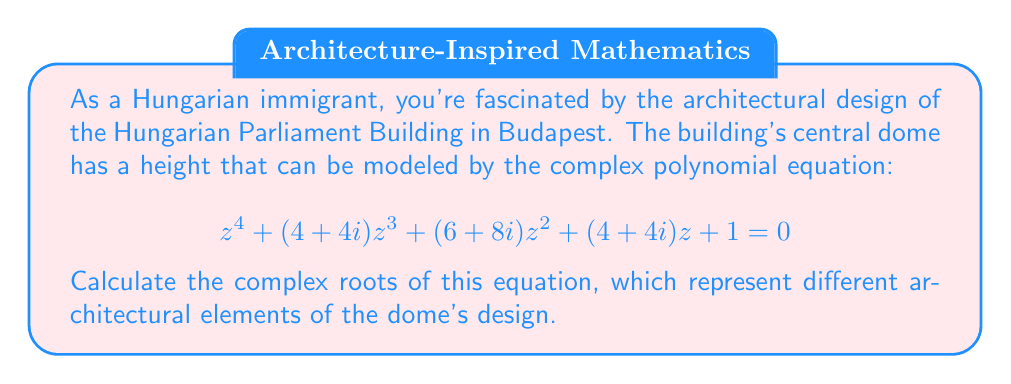Give your solution to this math problem. To solve this complex polynomial equation, we can use the following steps:

1) First, we recognize that this is a reciprocal polynomial, where the coefficients are symmetric. This means that if $z$ is a root, then $\frac{1}{z}$ is also a root.

2) We can factor the polynomial as:

   $$ (z^2 + az + 1)(z^2 + bz + 1) = 0 $$

   where $a$ and $b$ are complex numbers to be determined.

3) Expanding this factored form and equating coefficients with the original equation:

   $$ z^4 + (a+b)z^3 + (ab+2)z^2 + (a+b)z + 1 = z^4 + (4+4i)z^3 + (6+8i)z^2 + (4+4i)z + 1 $$

4) Equating coefficients:

   $a + b = 4 + 4i$
   $ab + 2 = 6 + 8i$

5) From the first equation: $b = (4+4i) - a$

6) Substituting into the second equation:

   $a((4+4i) - a) + 2 = 6 + 8i$
   $4a + 4ai - a^2 + 2 = 6 + 8i$

7) Separating real and imaginary parts:

   $4a - a^2 + 2 = 6$
   $4a = 8$

8) From the imaginary part: $a = 2$

9) Substituting back: $b = 2 + 4i$

10) Now we have two quadratic equations:

    $z^2 + 2z + 1 = 0$
    $z^2 + (2+4i)z + 1 = 0$

11) Solving these using the quadratic formula $z = \frac{-b \pm \sqrt{b^2 - 4ac}}{2a}$:

    For $z^2 + 2z + 1 = 0$:
    $z = -1 \pm \sqrt{1 - 1} = -1$

    For $z^2 + (2+4i)z + 1 = 0$:
    $z = \frac{-(2+4i) \pm \sqrt{(2+4i)^2 - 4}}{2}$
    $= \frac{-(2+4i) \pm \sqrt{-12-16i}}{2}$
    $= \frac{-(2+4i) \pm 2\sqrt{-3-4i}}{2}$
    $= -1-2i \pm \sqrt{-3-4i}$
Answer: The complex roots are:

$z_1 = z_2 = -1$
$z_3 = -1-2i + \sqrt{-3-4i}$
$z_4 = -1-2i - \sqrt{-3-4i}$ 